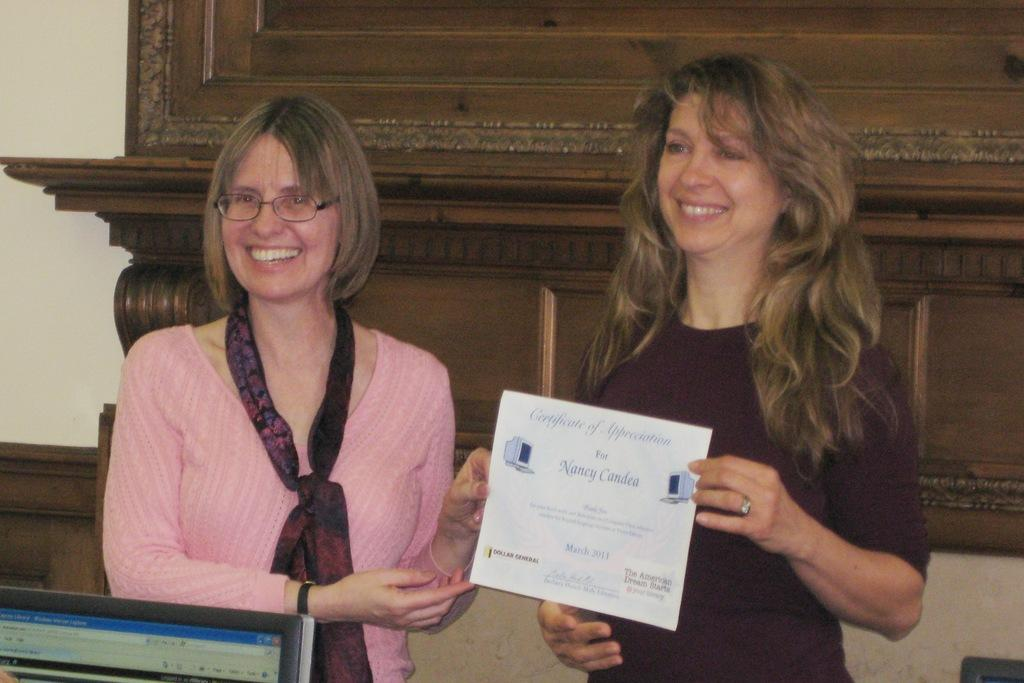Provide a one-sentence caption for the provided image. nancy Candea is being recognized with a certificate of appreciation. 